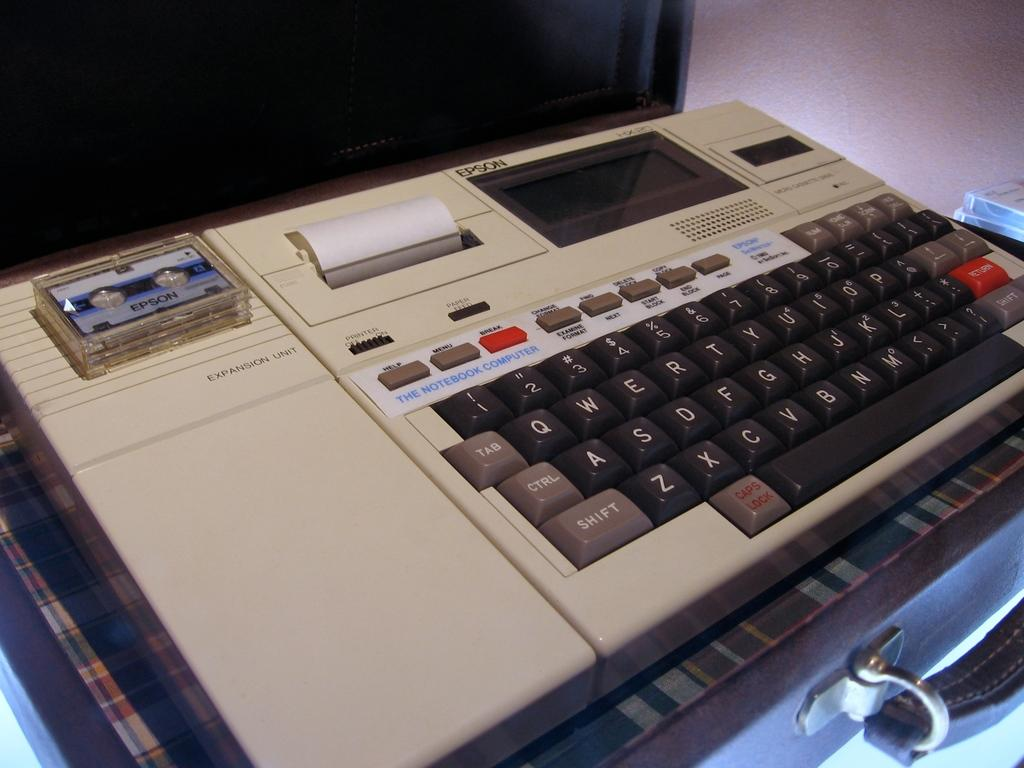<image>
Create a compact narrative representing the image presented. An old Epson notebook computer sits inside of a briefcase. 